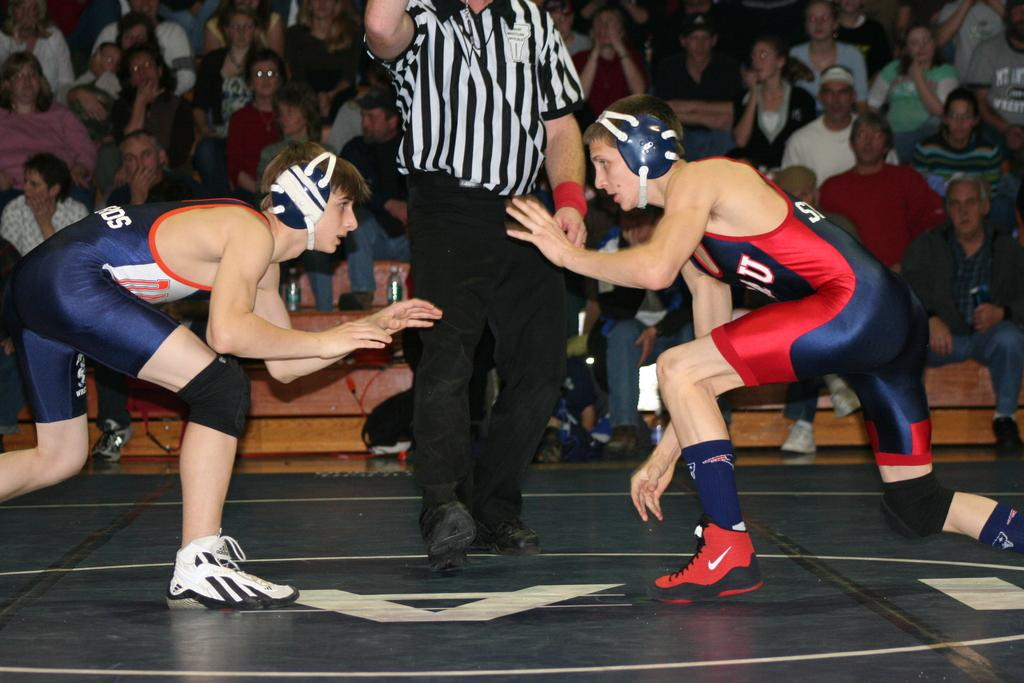Provide a one-sentence caption for the provided image. A wrestler in Adidas shoes stands facing a wrestler in shoes with a Nike swoosh on them. 